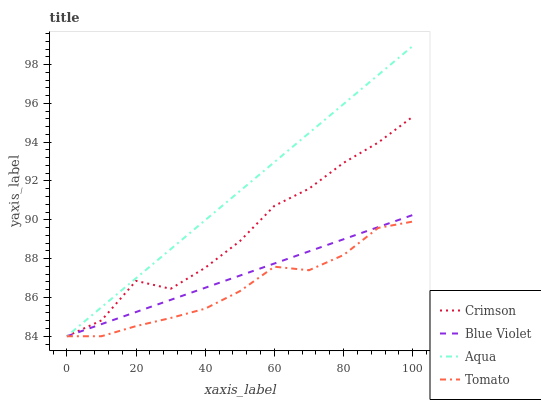Does Tomato have the minimum area under the curve?
Answer yes or no. Yes. Does Aqua have the maximum area under the curve?
Answer yes or no. Yes. Does Aqua have the minimum area under the curve?
Answer yes or no. No. Does Tomato have the maximum area under the curve?
Answer yes or no. No. Is Aqua the smoothest?
Answer yes or no. Yes. Is Crimson the roughest?
Answer yes or no. Yes. Is Tomato the smoothest?
Answer yes or no. No. Is Tomato the roughest?
Answer yes or no. No. Does Crimson have the lowest value?
Answer yes or no. Yes. Does Aqua have the highest value?
Answer yes or no. Yes. Does Tomato have the highest value?
Answer yes or no. No. Does Blue Violet intersect Tomato?
Answer yes or no. Yes. Is Blue Violet less than Tomato?
Answer yes or no. No. Is Blue Violet greater than Tomato?
Answer yes or no. No. 